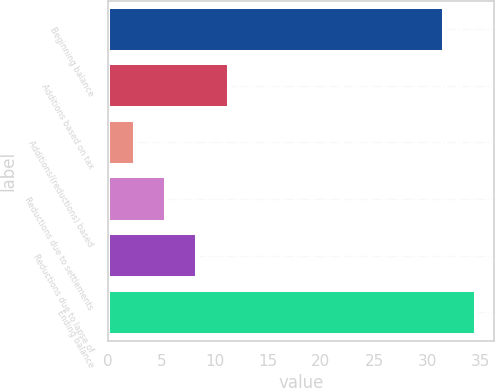Convert chart to OTSL. <chart><loc_0><loc_0><loc_500><loc_500><bar_chart><fcel>Beginning balance<fcel>Additions based on tax<fcel>Additions/(reductions) based<fcel>Reductions due to settlements<fcel>Reductions due to lapse of<fcel>Ending balance<nl><fcel>31.6<fcel>11.35<fcel>2.5<fcel>5.45<fcel>8.4<fcel>34.55<nl></chart> 